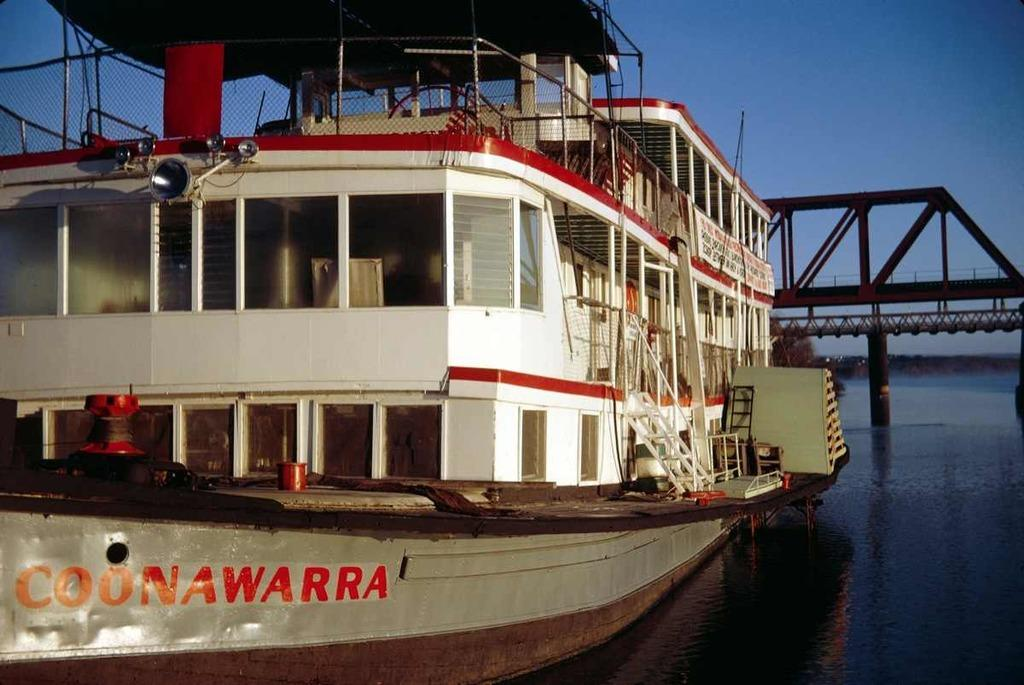What is the main subject of the image? The main subject of the image is a boat. Where is the boat located? The boat is on a river. What can be seen in the background of the image? There is a bridge behind the boat. What type of polish is being applied to the boat in the image? There is no indication in the image that any polish is being applied to the boat. How many people are in the group on the boat in the image? There is no group of people visible on the boat in the image. 